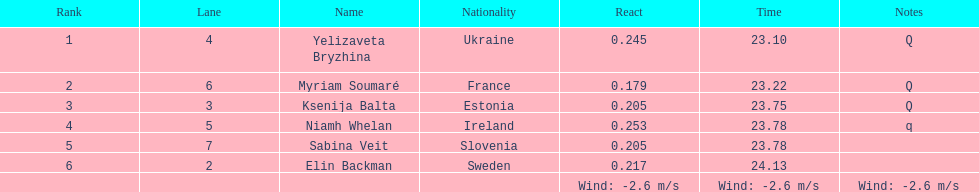Are any of the lanes in consecutive order? No. 